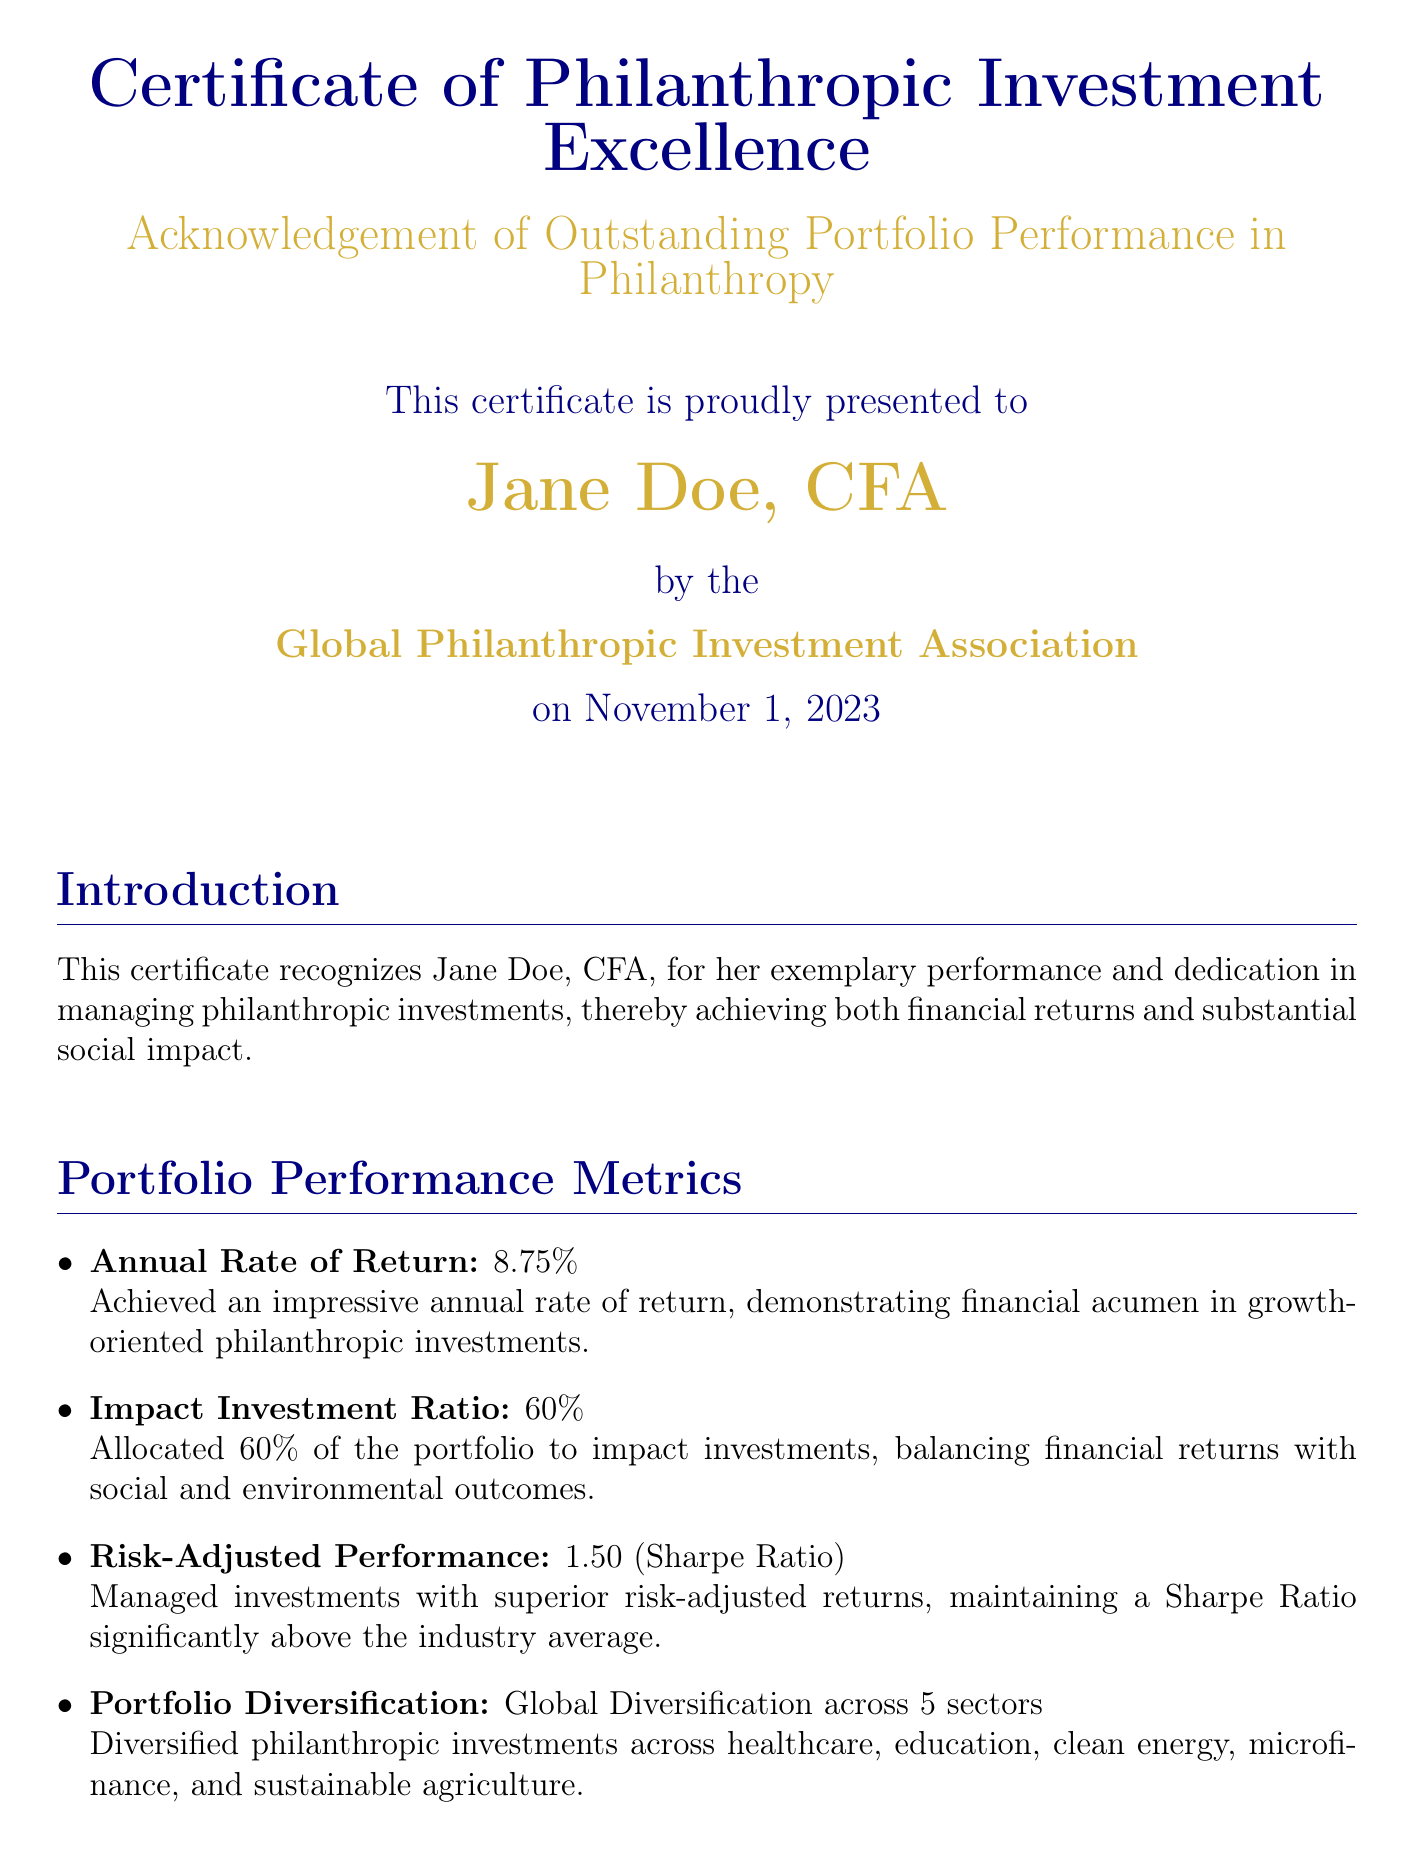What is the certificate title? The title of the certificate is stated in the header of the document.
Answer: Certificate of Philanthropic Investment Excellence Who is the recipient of the certificate? The recipient's name is prominently displayed on the certificate.
Answer: Jane Doe, CFA What is the date of the certificate issuance? The date is recorded in the document and signifies when the certificate was awarded.
Answer: November 1, 2023 What is the annual rate of return achieved? The annual rate of return is explicitly mentioned in the portfolio performance metrics section.
Answer: 8.75% What percentage of the portfolio is allocated to impact investments? The impact investment ratio detailing the allocation is provided in the performance metrics.
Answer: 60% What is the Sharpe Ratio mentioned in the document? The Sharpe Ratio is noted under risk-adjusted performance metrics, indicating the quality of risk management.
Answer: 1.50 How many sectors is the portfolio diversified across? The document specifies the number of sectors in the portfolio diversification section.
Answer: 5 What are two professional affiliations of Jane Doe? Jane Doe's professional affiliations are listed at the end of the document, showcasing her credentials.
Answer: GIIN and CFA Institute What type of certificate is this? The document type is indicated clearly at the beginning of the certificate.
Answer: Certificate 